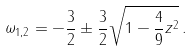Convert formula to latex. <formula><loc_0><loc_0><loc_500><loc_500>\omega _ { 1 , 2 } = - \frac { 3 } { 2 } \pm \frac { 3 } { 2 } \sqrt { 1 - \frac { 4 } { 9 } z ^ { 2 } } \, .</formula> 